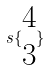<formula> <loc_0><loc_0><loc_500><loc_500>s \{ \begin{matrix} 4 \\ 3 \end{matrix} \}</formula> 